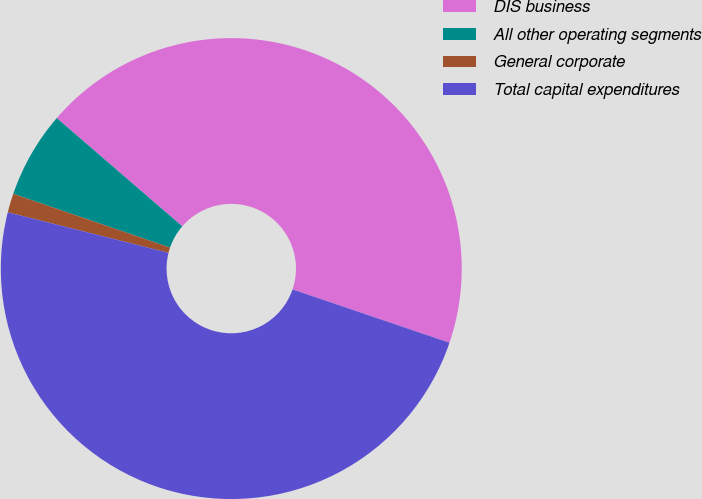Convert chart to OTSL. <chart><loc_0><loc_0><loc_500><loc_500><pie_chart><fcel>DIS business<fcel>All other operating segments<fcel>General corporate<fcel>Total capital expenditures<nl><fcel>43.89%<fcel>6.07%<fcel>1.33%<fcel>48.71%<nl></chart> 